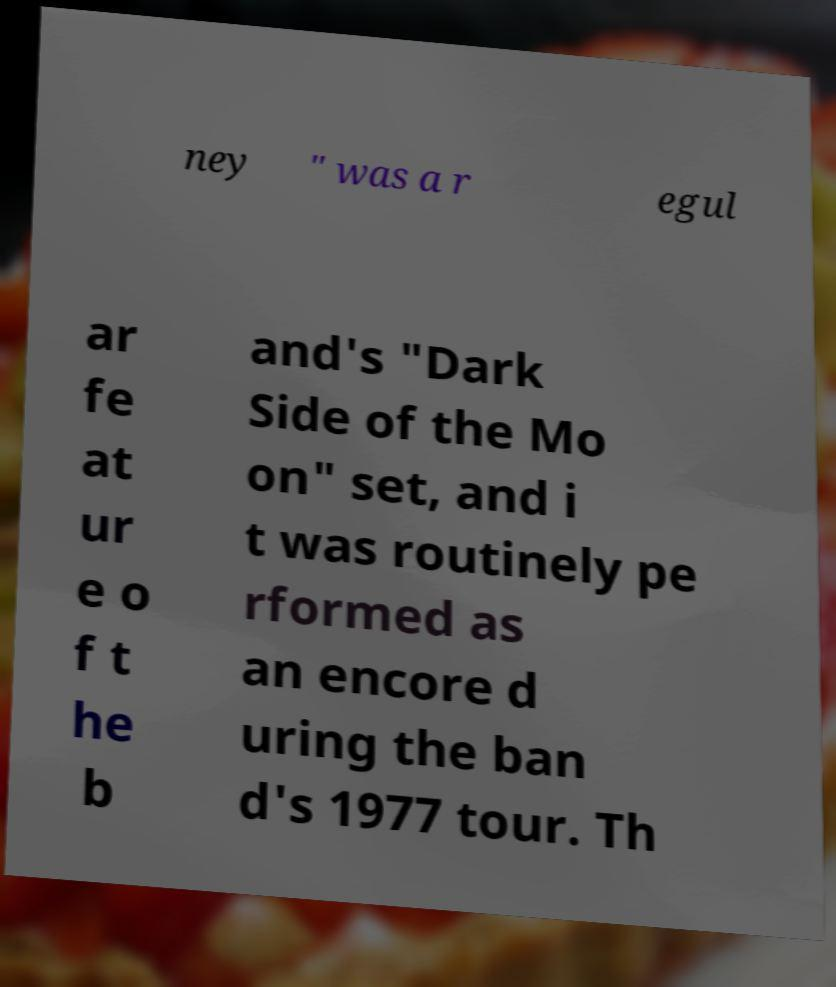Please identify and transcribe the text found in this image. ney " was a r egul ar fe at ur e o f t he b and's "Dark Side of the Mo on" set, and i t was routinely pe rformed as an encore d uring the ban d's 1977 tour. Th 